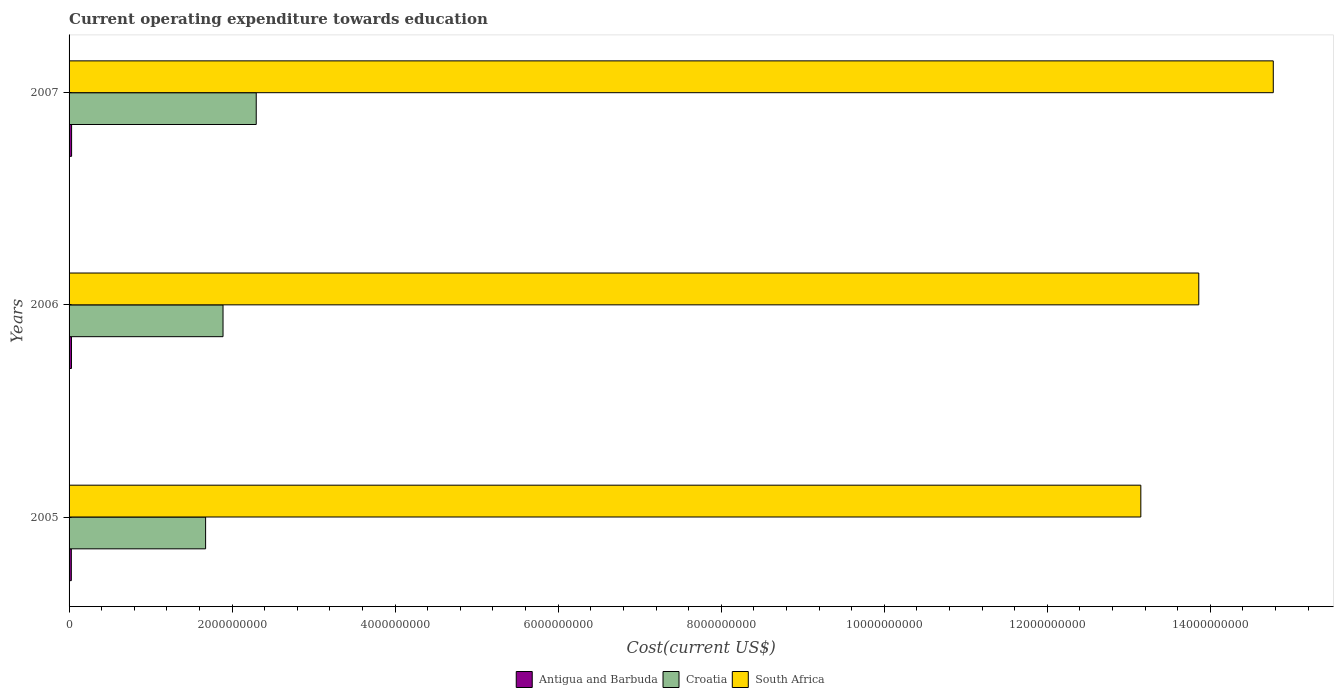How many different coloured bars are there?
Your answer should be very brief. 3. How many groups of bars are there?
Ensure brevity in your answer.  3. Are the number of bars on each tick of the Y-axis equal?
Make the answer very short. Yes. How many bars are there on the 1st tick from the bottom?
Your answer should be very brief. 3. In how many cases, is the number of bars for a given year not equal to the number of legend labels?
Provide a succinct answer. 0. What is the expenditure towards education in South Africa in 2007?
Offer a terse response. 1.48e+1. Across all years, what is the maximum expenditure towards education in Antigua and Barbuda?
Offer a very short reply. 3.09e+07. Across all years, what is the minimum expenditure towards education in Croatia?
Offer a terse response. 1.67e+09. In which year was the expenditure towards education in South Africa maximum?
Provide a succinct answer. 2007. What is the total expenditure towards education in Croatia in the graph?
Keep it short and to the point. 5.86e+09. What is the difference between the expenditure towards education in Antigua and Barbuda in 2005 and that in 2006?
Offer a very short reply. -1.68e+06. What is the difference between the expenditure towards education in Antigua and Barbuda in 2006 and the expenditure towards education in South Africa in 2005?
Your answer should be very brief. -1.31e+1. What is the average expenditure towards education in South Africa per year?
Keep it short and to the point. 1.39e+1. In the year 2005, what is the difference between the expenditure towards education in South Africa and expenditure towards education in Croatia?
Give a very brief answer. 1.15e+1. What is the ratio of the expenditure towards education in Antigua and Barbuda in 2006 to that in 2007?
Offer a very short reply. 0.95. What is the difference between the highest and the second highest expenditure towards education in Croatia?
Provide a short and direct response. 4.07e+08. What is the difference between the highest and the lowest expenditure towards education in South Africa?
Make the answer very short. 1.62e+09. In how many years, is the expenditure towards education in Croatia greater than the average expenditure towards education in Croatia taken over all years?
Provide a succinct answer. 1. Is the sum of the expenditure towards education in Croatia in 2006 and 2007 greater than the maximum expenditure towards education in Antigua and Barbuda across all years?
Give a very brief answer. Yes. What does the 3rd bar from the top in 2006 represents?
Your response must be concise. Antigua and Barbuda. What does the 2nd bar from the bottom in 2005 represents?
Your response must be concise. Croatia. How many bars are there?
Your answer should be very brief. 9. Does the graph contain any zero values?
Your answer should be compact. No. What is the title of the graph?
Your answer should be compact. Current operating expenditure towards education. Does "Maldives" appear as one of the legend labels in the graph?
Your response must be concise. No. What is the label or title of the X-axis?
Offer a very short reply. Cost(current US$). What is the label or title of the Y-axis?
Provide a succinct answer. Years. What is the Cost(current US$) of Antigua and Barbuda in 2005?
Provide a short and direct response. 2.77e+07. What is the Cost(current US$) in Croatia in 2005?
Offer a terse response. 1.67e+09. What is the Cost(current US$) in South Africa in 2005?
Offer a very short reply. 1.31e+1. What is the Cost(current US$) in Antigua and Barbuda in 2006?
Provide a succinct answer. 2.94e+07. What is the Cost(current US$) of Croatia in 2006?
Give a very brief answer. 1.89e+09. What is the Cost(current US$) of South Africa in 2006?
Offer a terse response. 1.39e+1. What is the Cost(current US$) of Antigua and Barbuda in 2007?
Provide a succinct answer. 3.09e+07. What is the Cost(current US$) in Croatia in 2007?
Your response must be concise. 2.30e+09. What is the Cost(current US$) of South Africa in 2007?
Offer a terse response. 1.48e+1. Across all years, what is the maximum Cost(current US$) of Antigua and Barbuda?
Make the answer very short. 3.09e+07. Across all years, what is the maximum Cost(current US$) in Croatia?
Make the answer very short. 2.30e+09. Across all years, what is the maximum Cost(current US$) in South Africa?
Ensure brevity in your answer.  1.48e+1. Across all years, what is the minimum Cost(current US$) of Antigua and Barbuda?
Give a very brief answer. 2.77e+07. Across all years, what is the minimum Cost(current US$) in Croatia?
Offer a terse response. 1.67e+09. Across all years, what is the minimum Cost(current US$) in South Africa?
Offer a terse response. 1.31e+1. What is the total Cost(current US$) in Antigua and Barbuda in the graph?
Offer a terse response. 8.80e+07. What is the total Cost(current US$) in Croatia in the graph?
Keep it short and to the point. 5.86e+09. What is the total Cost(current US$) of South Africa in the graph?
Your answer should be very brief. 4.18e+1. What is the difference between the Cost(current US$) in Antigua and Barbuda in 2005 and that in 2006?
Your response must be concise. -1.68e+06. What is the difference between the Cost(current US$) in Croatia in 2005 and that in 2006?
Your response must be concise. -2.14e+08. What is the difference between the Cost(current US$) of South Africa in 2005 and that in 2006?
Offer a very short reply. -7.11e+08. What is the difference between the Cost(current US$) in Antigua and Barbuda in 2005 and that in 2007?
Ensure brevity in your answer.  -3.21e+06. What is the difference between the Cost(current US$) in Croatia in 2005 and that in 2007?
Your answer should be compact. -6.21e+08. What is the difference between the Cost(current US$) in South Africa in 2005 and that in 2007?
Offer a terse response. -1.62e+09. What is the difference between the Cost(current US$) in Antigua and Barbuda in 2006 and that in 2007?
Give a very brief answer. -1.53e+06. What is the difference between the Cost(current US$) in Croatia in 2006 and that in 2007?
Keep it short and to the point. -4.07e+08. What is the difference between the Cost(current US$) in South Africa in 2006 and that in 2007?
Ensure brevity in your answer.  -9.14e+08. What is the difference between the Cost(current US$) in Antigua and Barbuda in 2005 and the Cost(current US$) in Croatia in 2006?
Your answer should be compact. -1.86e+09. What is the difference between the Cost(current US$) in Antigua and Barbuda in 2005 and the Cost(current US$) in South Africa in 2006?
Give a very brief answer. -1.38e+1. What is the difference between the Cost(current US$) in Croatia in 2005 and the Cost(current US$) in South Africa in 2006?
Keep it short and to the point. -1.22e+1. What is the difference between the Cost(current US$) of Antigua and Barbuda in 2005 and the Cost(current US$) of Croatia in 2007?
Offer a very short reply. -2.27e+09. What is the difference between the Cost(current US$) of Antigua and Barbuda in 2005 and the Cost(current US$) of South Africa in 2007?
Provide a succinct answer. -1.47e+1. What is the difference between the Cost(current US$) in Croatia in 2005 and the Cost(current US$) in South Africa in 2007?
Ensure brevity in your answer.  -1.31e+1. What is the difference between the Cost(current US$) in Antigua and Barbuda in 2006 and the Cost(current US$) in Croatia in 2007?
Provide a succinct answer. -2.27e+09. What is the difference between the Cost(current US$) in Antigua and Barbuda in 2006 and the Cost(current US$) in South Africa in 2007?
Your answer should be compact. -1.47e+1. What is the difference between the Cost(current US$) of Croatia in 2006 and the Cost(current US$) of South Africa in 2007?
Your answer should be very brief. -1.29e+1. What is the average Cost(current US$) of Antigua and Barbuda per year?
Offer a terse response. 2.93e+07. What is the average Cost(current US$) in Croatia per year?
Offer a terse response. 1.95e+09. What is the average Cost(current US$) of South Africa per year?
Offer a terse response. 1.39e+1. In the year 2005, what is the difference between the Cost(current US$) in Antigua and Barbuda and Cost(current US$) in Croatia?
Your response must be concise. -1.65e+09. In the year 2005, what is the difference between the Cost(current US$) in Antigua and Barbuda and Cost(current US$) in South Africa?
Give a very brief answer. -1.31e+1. In the year 2005, what is the difference between the Cost(current US$) of Croatia and Cost(current US$) of South Africa?
Ensure brevity in your answer.  -1.15e+1. In the year 2006, what is the difference between the Cost(current US$) in Antigua and Barbuda and Cost(current US$) in Croatia?
Your response must be concise. -1.86e+09. In the year 2006, what is the difference between the Cost(current US$) of Antigua and Barbuda and Cost(current US$) of South Africa?
Make the answer very short. -1.38e+1. In the year 2006, what is the difference between the Cost(current US$) in Croatia and Cost(current US$) in South Africa?
Keep it short and to the point. -1.20e+1. In the year 2007, what is the difference between the Cost(current US$) in Antigua and Barbuda and Cost(current US$) in Croatia?
Offer a very short reply. -2.27e+09. In the year 2007, what is the difference between the Cost(current US$) of Antigua and Barbuda and Cost(current US$) of South Africa?
Ensure brevity in your answer.  -1.47e+1. In the year 2007, what is the difference between the Cost(current US$) in Croatia and Cost(current US$) in South Africa?
Offer a terse response. -1.25e+1. What is the ratio of the Cost(current US$) of Antigua and Barbuda in 2005 to that in 2006?
Your answer should be very brief. 0.94. What is the ratio of the Cost(current US$) of Croatia in 2005 to that in 2006?
Offer a terse response. 0.89. What is the ratio of the Cost(current US$) in South Africa in 2005 to that in 2006?
Offer a terse response. 0.95. What is the ratio of the Cost(current US$) of Antigua and Barbuda in 2005 to that in 2007?
Make the answer very short. 0.9. What is the ratio of the Cost(current US$) of Croatia in 2005 to that in 2007?
Provide a short and direct response. 0.73. What is the ratio of the Cost(current US$) of South Africa in 2005 to that in 2007?
Your answer should be very brief. 0.89. What is the ratio of the Cost(current US$) in Antigua and Barbuda in 2006 to that in 2007?
Your response must be concise. 0.95. What is the ratio of the Cost(current US$) in Croatia in 2006 to that in 2007?
Keep it short and to the point. 0.82. What is the ratio of the Cost(current US$) in South Africa in 2006 to that in 2007?
Offer a terse response. 0.94. What is the difference between the highest and the second highest Cost(current US$) in Antigua and Barbuda?
Your response must be concise. 1.53e+06. What is the difference between the highest and the second highest Cost(current US$) of Croatia?
Offer a very short reply. 4.07e+08. What is the difference between the highest and the second highest Cost(current US$) in South Africa?
Give a very brief answer. 9.14e+08. What is the difference between the highest and the lowest Cost(current US$) in Antigua and Barbuda?
Make the answer very short. 3.21e+06. What is the difference between the highest and the lowest Cost(current US$) of Croatia?
Give a very brief answer. 6.21e+08. What is the difference between the highest and the lowest Cost(current US$) in South Africa?
Offer a very short reply. 1.62e+09. 